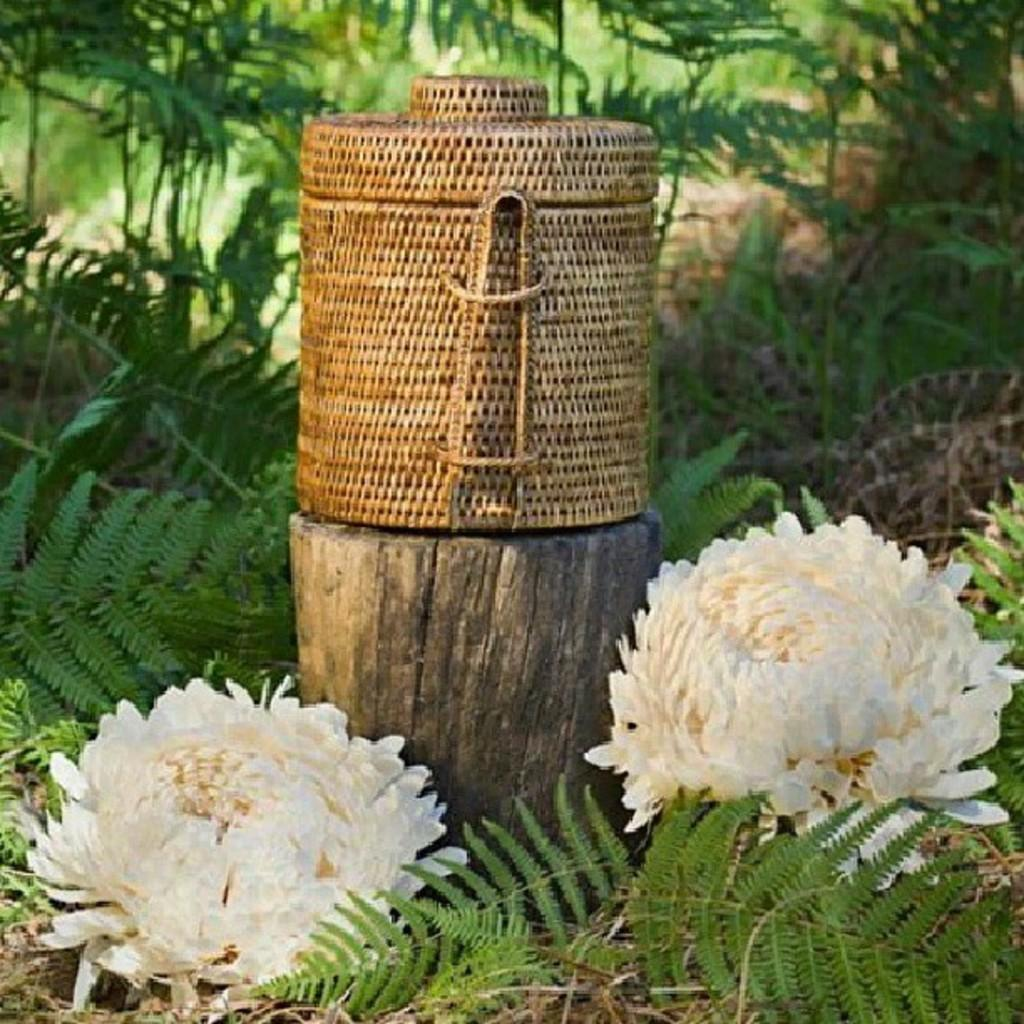What is located in the center of the image? There is a basket in the center of the image. What object can be seen standing upright in the image? There is a wooden pole in the image. What type of vegetation is at the bottom of the image? There are flowers and plants at the bottom of the image. What can be seen in the distance in the image? There are trees in the background of the image. Can you hear the ear whistling in the image? There is no ear or whistling present in the image. What color is the leaf on the wooden pole? There is no leaf on the wooden pole in the image. 